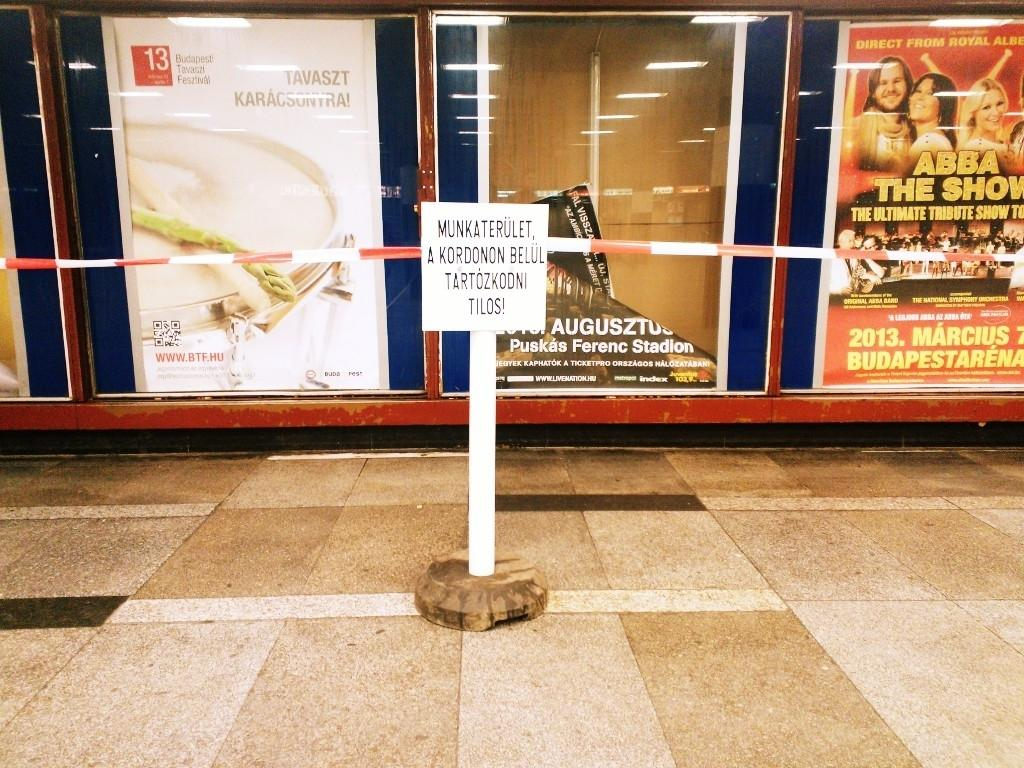<image>
Relay a brief, clear account of the picture shown. Signs for Tavaszt Karacsonyra and an Abba Tribute show flank an event sign that has fallen down. 